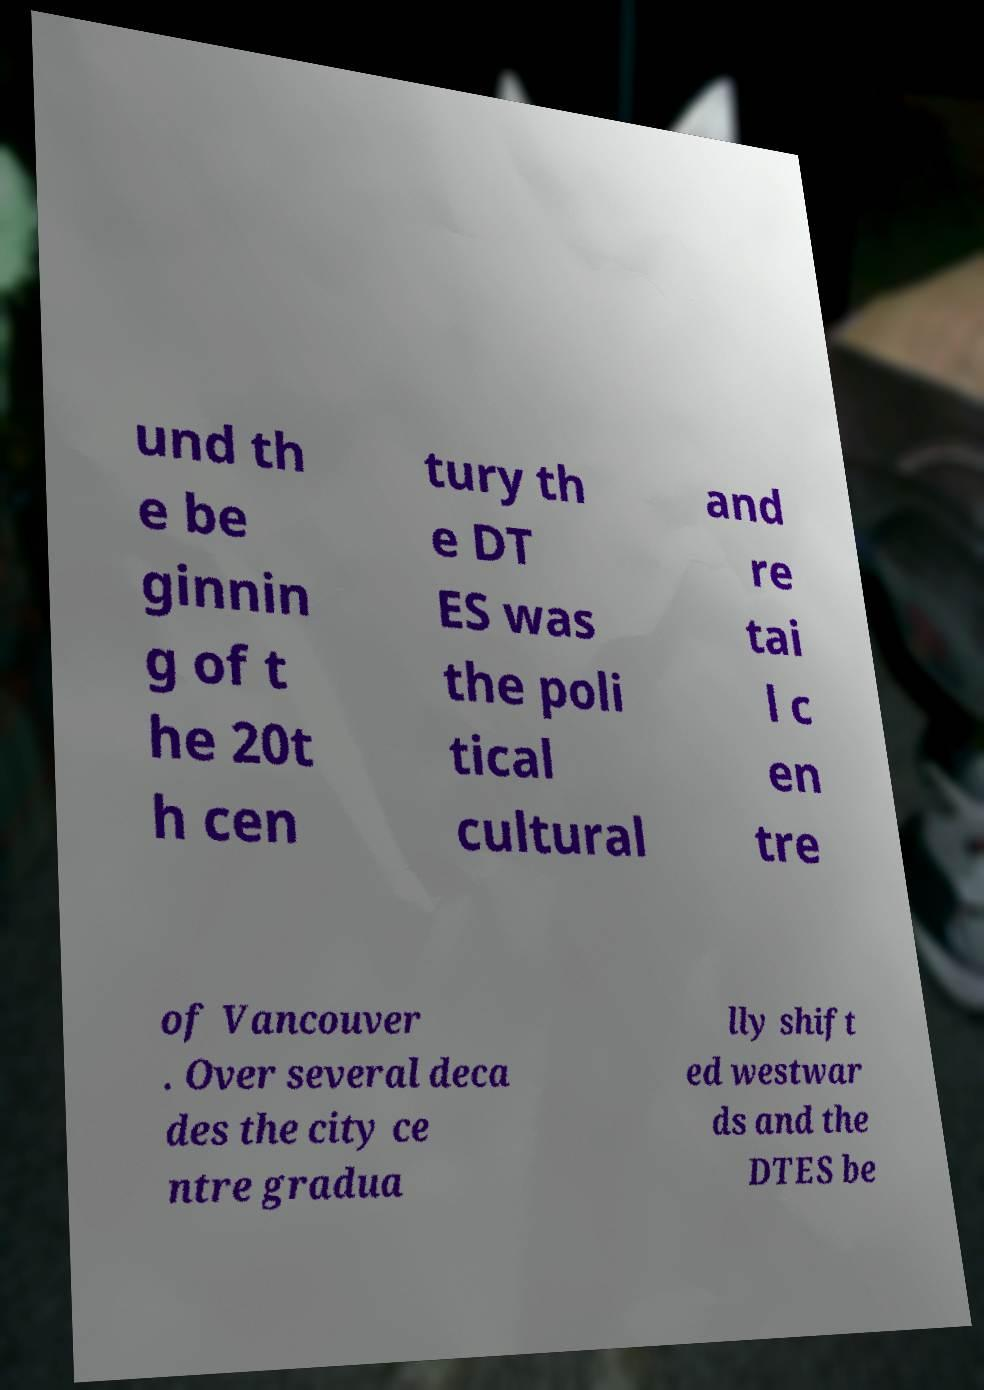Could you assist in decoding the text presented in this image and type it out clearly? und th e be ginnin g of t he 20t h cen tury th e DT ES was the poli tical cultural and re tai l c en tre of Vancouver . Over several deca des the city ce ntre gradua lly shift ed westwar ds and the DTES be 